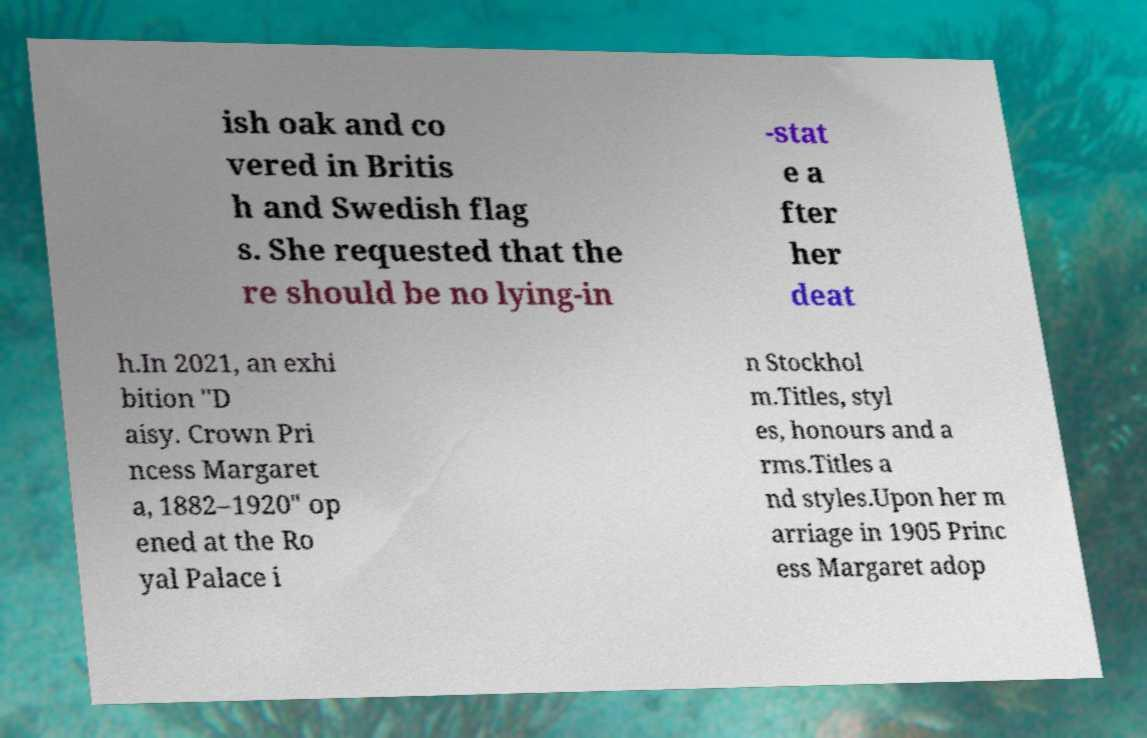For documentation purposes, I need the text within this image transcribed. Could you provide that? ish oak and co vered in Britis h and Swedish flag s. She requested that the re should be no lying-in -stat e a fter her deat h.In 2021, an exhi bition "D aisy. Crown Pri ncess Margaret a, 1882–1920" op ened at the Ro yal Palace i n Stockhol m.Titles, styl es, honours and a rms.Titles a nd styles.Upon her m arriage in 1905 Princ ess Margaret adop 